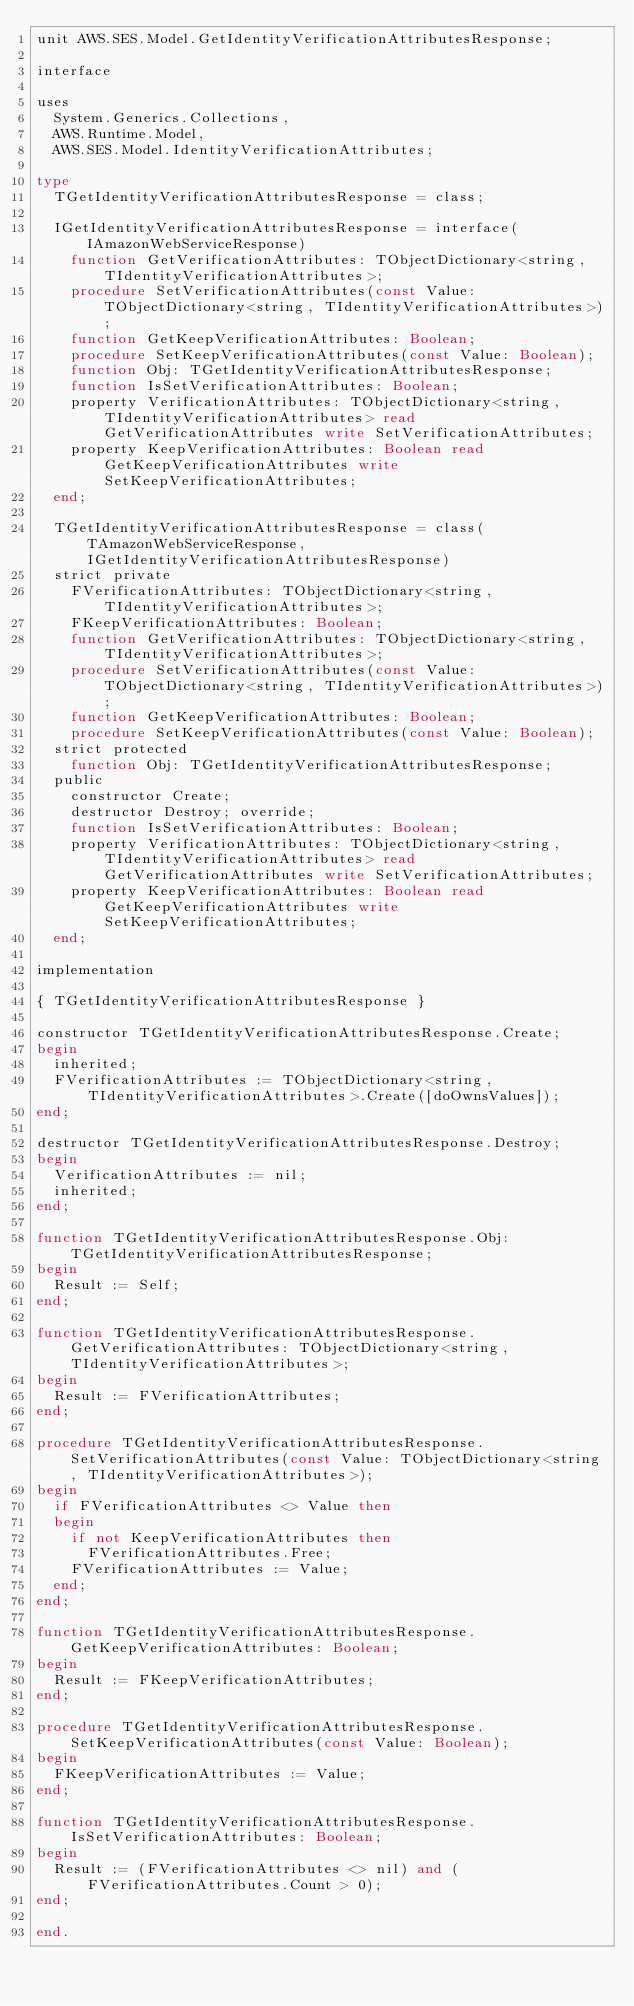<code> <loc_0><loc_0><loc_500><loc_500><_Pascal_>unit AWS.SES.Model.GetIdentityVerificationAttributesResponse;

interface

uses
  System.Generics.Collections, 
  AWS.Runtime.Model, 
  AWS.SES.Model.IdentityVerificationAttributes;

type
  TGetIdentityVerificationAttributesResponse = class;
  
  IGetIdentityVerificationAttributesResponse = interface(IAmazonWebServiceResponse)
    function GetVerificationAttributes: TObjectDictionary<string, TIdentityVerificationAttributes>;
    procedure SetVerificationAttributes(const Value: TObjectDictionary<string, TIdentityVerificationAttributes>);
    function GetKeepVerificationAttributes: Boolean;
    procedure SetKeepVerificationAttributes(const Value: Boolean);
    function Obj: TGetIdentityVerificationAttributesResponse;
    function IsSetVerificationAttributes: Boolean;
    property VerificationAttributes: TObjectDictionary<string, TIdentityVerificationAttributes> read GetVerificationAttributes write SetVerificationAttributes;
    property KeepVerificationAttributes: Boolean read GetKeepVerificationAttributes write SetKeepVerificationAttributes;
  end;
  
  TGetIdentityVerificationAttributesResponse = class(TAmazonWebServiceResponse, IGetIdentityVerificationAttributesResponse)
  strict private
    FVerificationAttributes: TObjectDictionary<string, TIdentityVerificationAttributes>;
    FKeepVerificationAttributes: Boolean;
    function GetVerificationAttributes: TObjectDictionary<string, TIdentityVerificationAttributes>;
    procedure SetVerificationAttributes(const Value: TObjectDictionary<string, TIdentityVerificationAttributes>);
    function GetKeepVerificationAttributes: Boolean;
    procedure SetKeepVerificationAttributes(const Value: Boolean);
  strict protected
    function Obj: TGetIdentityVerificationAttributesResponse;
  public
    constructor Create;
    destructor Destroy; override;
    function IsSetVerificationAttributes: Boolean;
    property VerificationAttributes: TObjectDictionary<string, TIdentityVerificationAttributes> read GetVerificationAttributes write SetVerificationAttributes;
    property KeepVerificationAttributes: Boolean read GetKeepVerificationAttributes write SetKeepVerificationAttributes;
  end;
  
implementation

{ TGetIdentityVerificationAttributesResponse }

constructor TGetIdentityVerificationAttributesResponse.Create;
begin
  inherited;
  FVerificationAttributes := TObjectDictionary<string, TIdentityVerificationAttributes>.Create([doOwnsValues]);
end;

destructor TGetIdentityVerificationAttributesResponse.Destroy;
begin
  VerificationAttributes := nil;
  inherited;
end;

function TGetIdentityVerificationAttributesResponse.Obj: TGetIdentityVerificationAttributesResponse;
begin
  Result := Self;
end;

function TGetIdentityVerificationAttributesResponse.GetVerificationAttributes: TObjectDictionary<string, TIdentityVerificationAttributes>;
begin
  Result := FVerificationAttributes;
end;

procedure TGetIdentityVerificationAttributesResponse.SetVerificationAttributes(const Value: TObjectDictionary<string, TIdentityVerificationAttributes>);
begin
  if FVerificationAttributes <> Value then
  begin
    if not KeepVerificationAttributes then
      FVerificationAttributes.Free;
    FVerificationAttributes := Value;
  end;
end;

function TGetIdentityVerificationAttributesResponse.GetKeepVerificationAttributes: Boolean;
begin
  Result := FKeepVerificationAttributes;
end;

procedure TGetIdentityVerificationAttributesResponse.SetKeepVerificationAttributes(const Value: Boolean);
begin
  FKeepVerificationAttributes := Value;
end;

function TGetIdentityVerificationAttributesResponse.IsSetVerificationAttributes: Boolean;
begin
  Result := (FVerificationAttributes <> nil) and (FVerificationAttributes.Count > 0);
end;

end.
</code> 